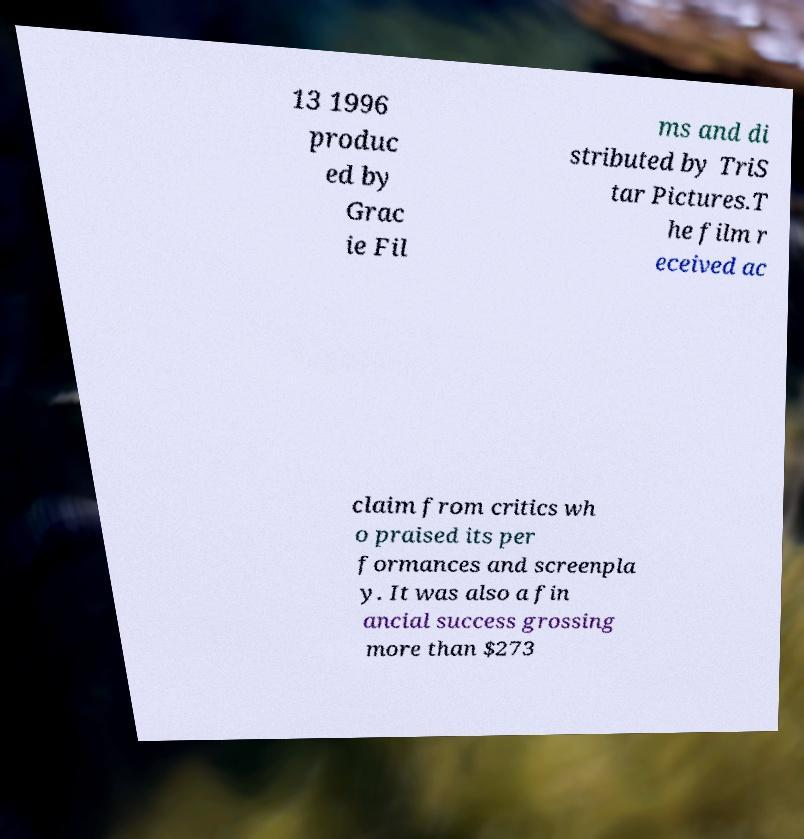Could you extract and type out the text from this image? 13 1996 produc ed by Grac ie Fil ms and di stributed by TriS tar Pictures.T he film r eceived ac claim from critics wh o praised its per formances and screenpla y. It was also a fin ancial success grossing more than $273 